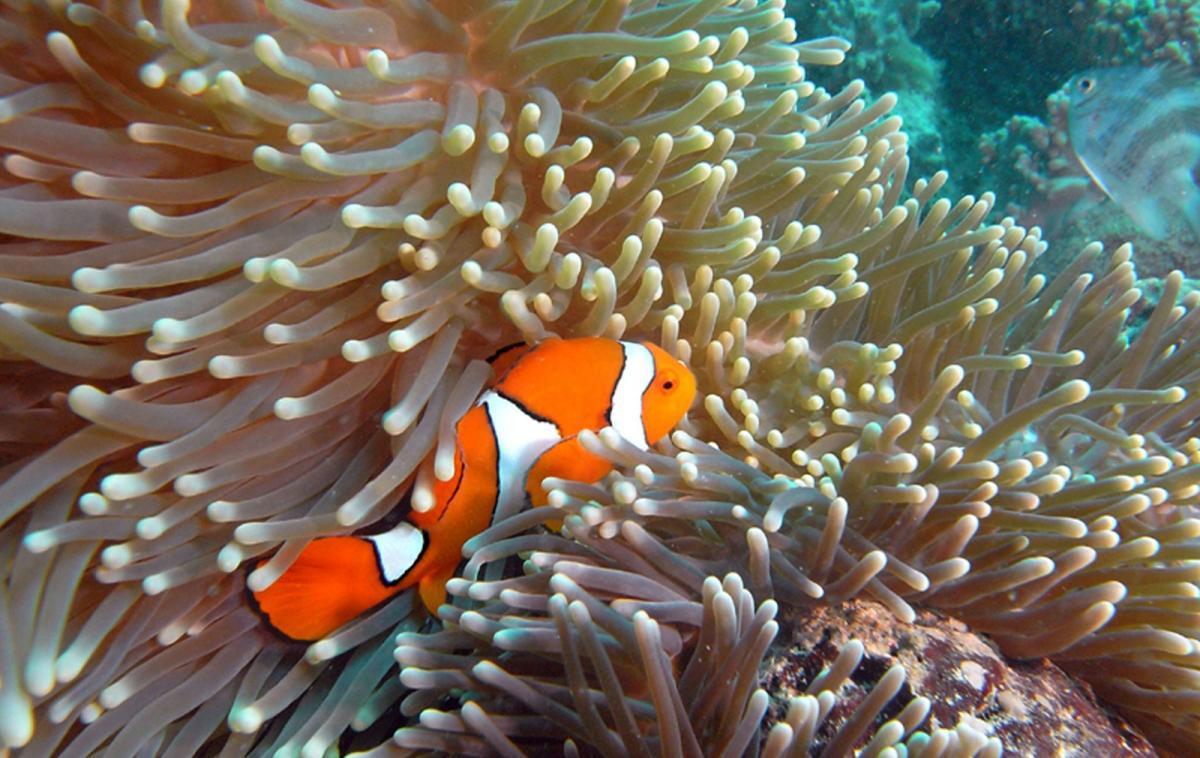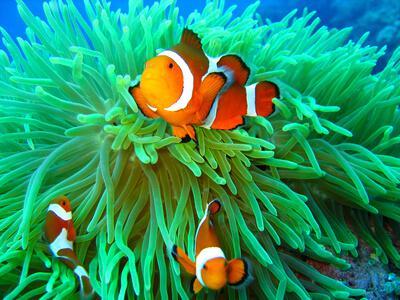The first image is the image on the left, the second image is the image on the right. Assess this claim about the two images: "There are two fish in the picture on the left.". Correct or not? Answer yes or no. No. 